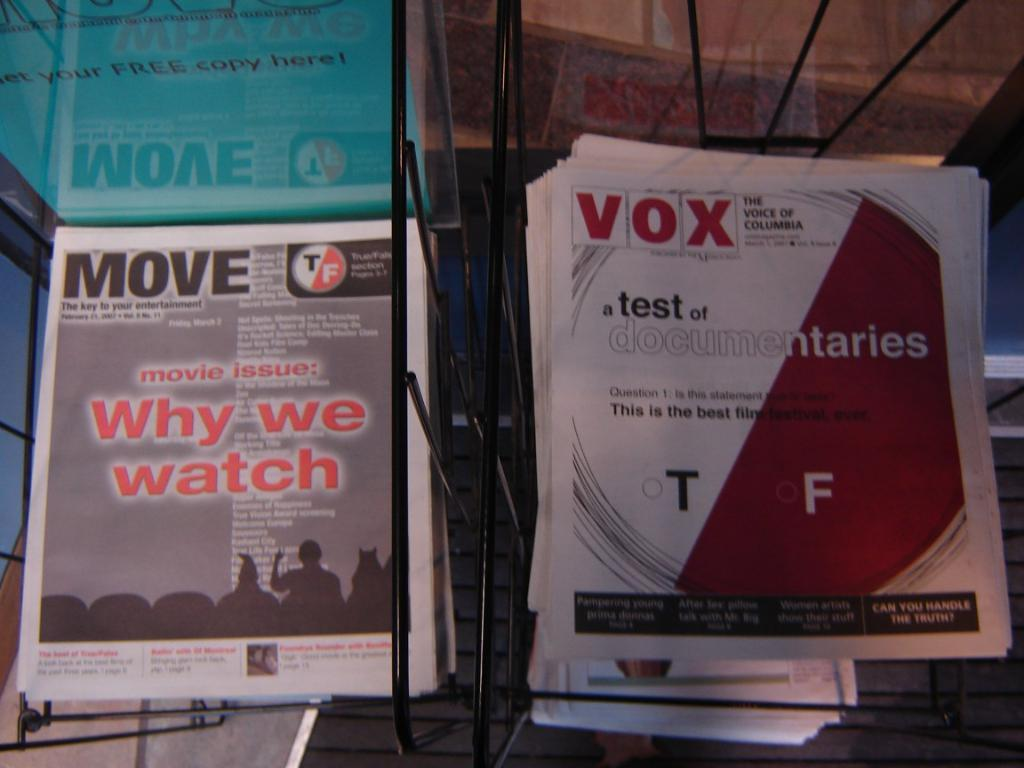Provide a one-sentence caption for the provided image. Move and Vox newsletters are placed in side-by-side racks. 